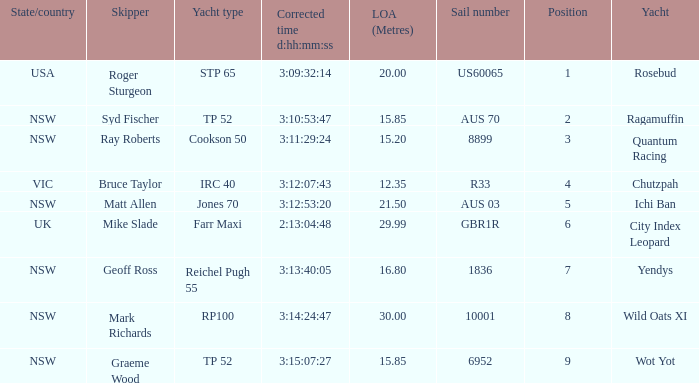Could you help me parse every detail presented in this table? {'header': ['State/country', 'Skipper', 'Yacht type', 'Corrected time d:hh:mm:ss', 'LOA (Metres)', 'Sail number', 'Position', 'Yacht'], 'rows': [['USA', 'Roger Sturgeon', 'STP 65', '3:09:32:14', '20.00', 'US60065', '1', 'Rosebud'], ['NSW', 'Syd Fischer', 'TP 52', '3:10:53:47', '15.85', 'AUS 70', '2', 'Ragamuffin'], ['NSW', 'Ray Roberts', 'Cookson 50', '3:11:29:24', '15.20', '8899', '3', 'Quantum Racing'], ['VIC', 'Bruce Taylor', 'IRC 40', '3:12:07:43', '12.35', 'R33', '4', 'Chutzpah'], ['NSW', 'Matt Allen', 'Jones 70', '3:12:53:20', '21.50', 'AUS 03', '5', 'Ichi Ban'], ['UK', 'Mike Slade', 'Farr Maxi', '2:13:04:48', '29.99', 'GBR1R', '6', 'City Index Leopard'], ['NSW', 'Geoff Ross', 'Reichel Pugh 55', '3:13:40:05', '16.80', '1836', '7', 'Yendys'], ['NSW', 'Mark Richards', 'RP100', '3:14:24:47', '30.00', '10001', '8', 'Wild Oats XI'], ['NSW', 'Graeme Wood', 'TP 52', '3:15:07:27', '15.85', '6952', '9', 'Wot Yot']]} What were all Yachts with a sail number of 6952? Wot Yot. 